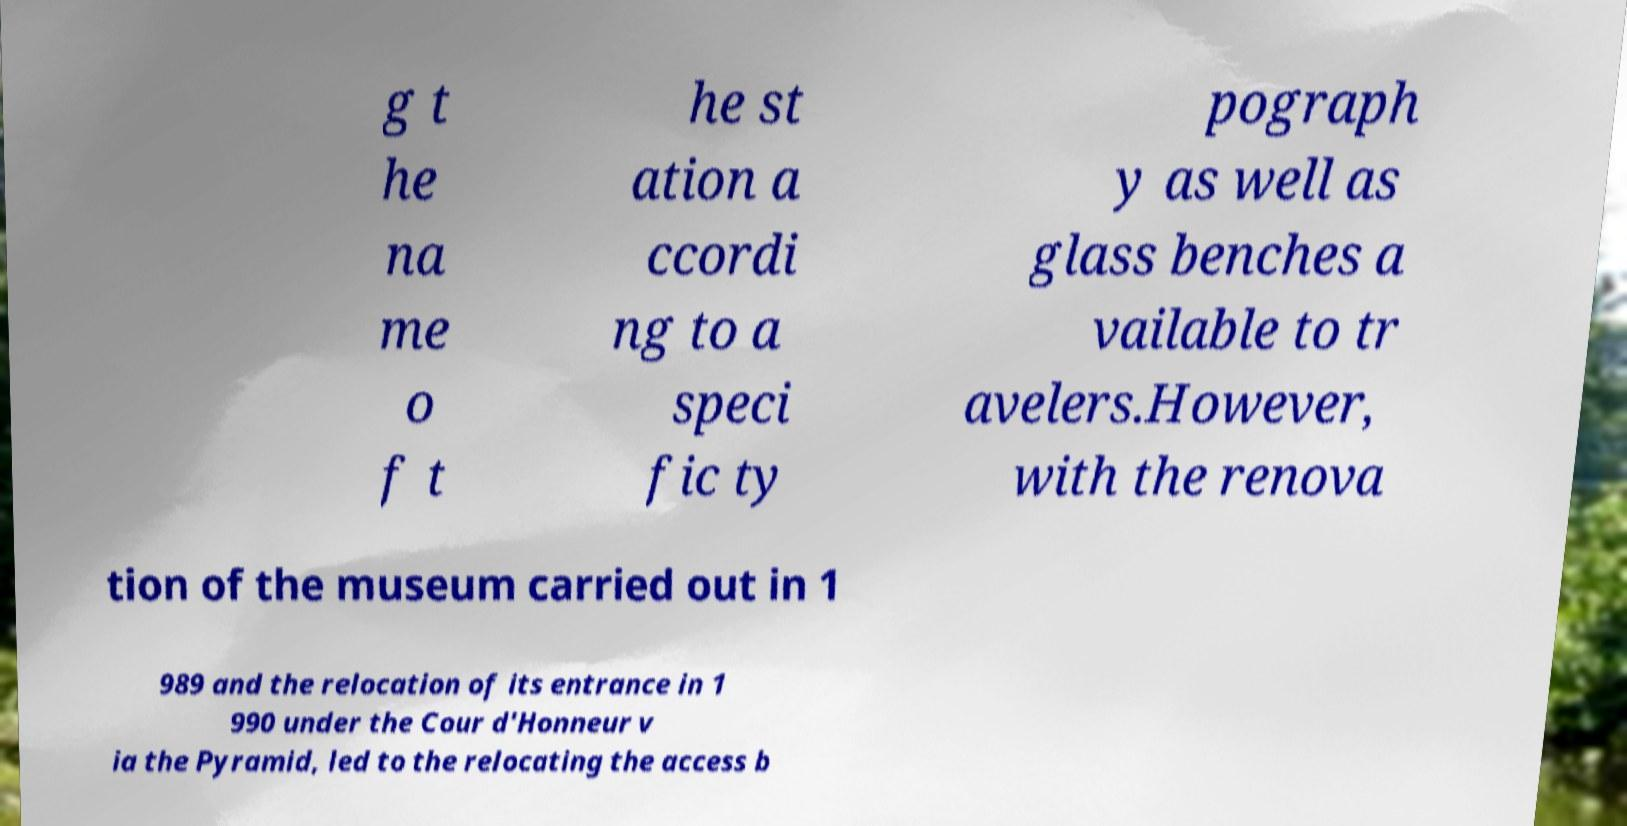What messages or text are displayed in this image? I need them in a readable, typed format. g t he na me o f t he st ation a ccordi ng to a speci fic ty pograph y as well as glass benches a vailable to tr avelers.However, with the renova tion of the museum carried out in 1 989 and the relocation of its entrance in 1 990 under the Cour d'Honneur v ia the Pyramid, led to the relocating the access b 